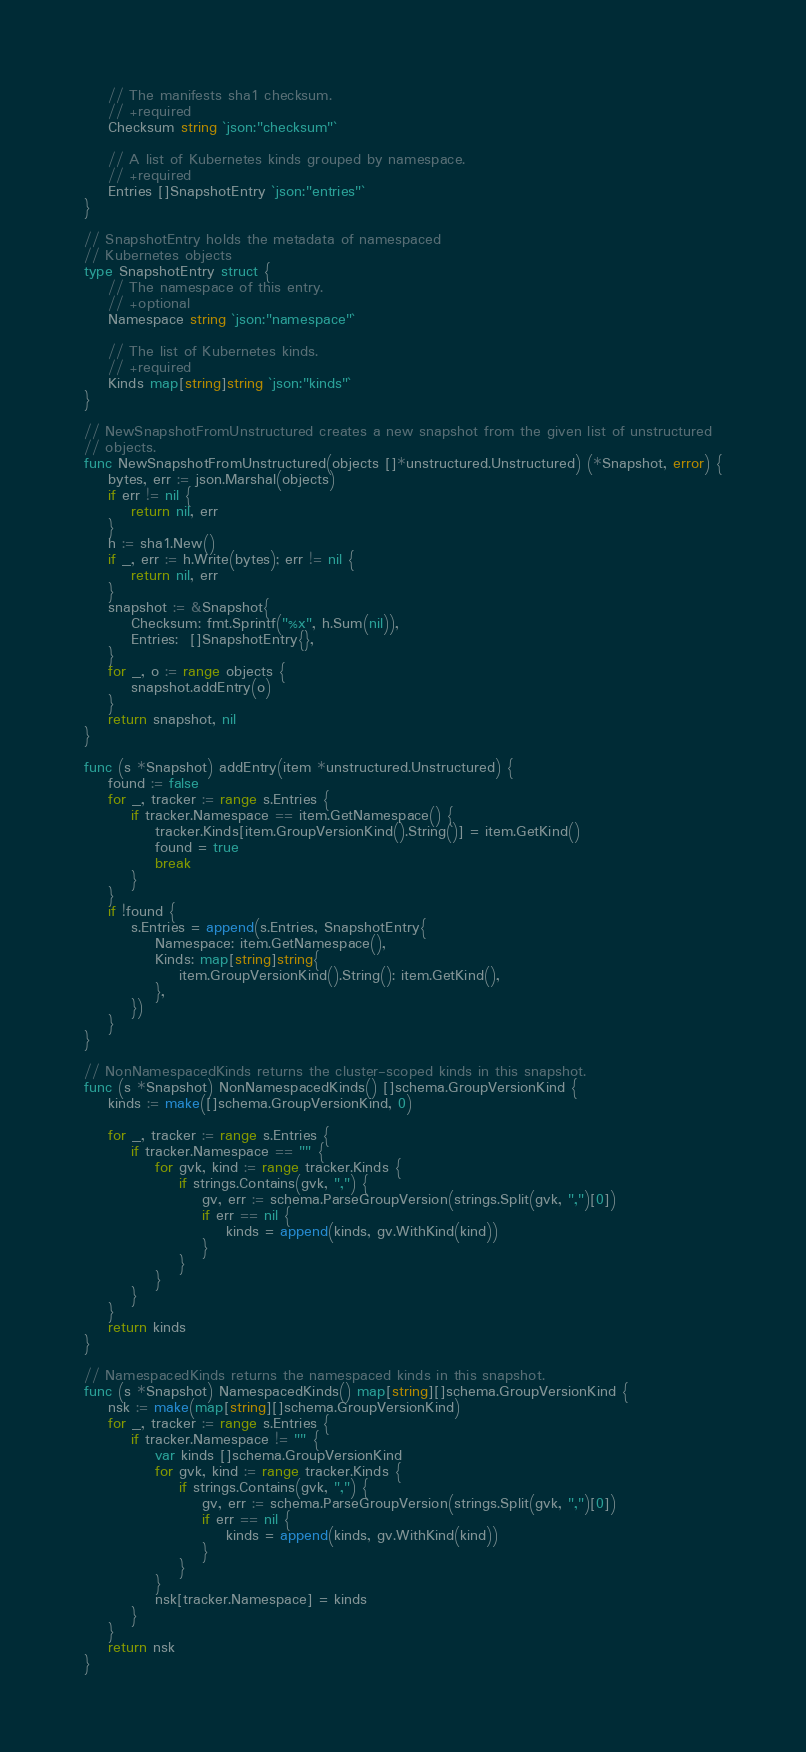Convert code to text. <code><loc_0><loc_0><loc_500><loc_500><_Go_>	// The manifests sha1 checksum.
	// +required
	Checksum string `json:"checksum"`

	// A list of Kubernetes kinds grouped by namespace.
	// +required
	Entries []SnapshotEntry `json:"entries"`
}

// SnapshotEntry holds the metadata of namespaced
// Kubernetes objects
type SnapshotEntry struct {
	// The namespace of this entry.
	// +optional
	Namespace string `json:"namespace"`

	// The list of Kubernetes kinds.
	// +required
	Kinds map[string]string `json:"kinds"`
}

// NewSnapshotFromUnstructured creates a new snapshot from the given list of unstructured
// objects.
func NewSnapshotFromUnstructured(objects []*unstructured.Unstructured) (*Snapshot, error) {
	bytes, err := json.Marshal(objects)
	if err != nil {
		return nil, err
	}
	h := sha1.New()
	if _, err := h.Write(bytes); err != nil {
		return nil, err
	}
	snapshot := &Snapshot{
		Checksum: fmt.Sprintf("%x", h.Sum(nil)),
		Entries:  []SnapshotEntry{},
	}
	for _, o := range objects {
		snapshot.addEntry(o)
	}
	return snapshot, nil
}

func (s *Snapshot) addEntry(item *unstructured.Unstructured) {
	found := false
	for _, tracker := range s.Entries {
		if tracker.Namespace == item.GetNamespace() {
			tracker.Kinds[item.GroupVersionKind().String()] = item.GetKind()
			found = true
			break
		}
	}
	if !found {
		s.Entries = append(s.Entries, SnapshotEntry{
			Namespace: item.GetNamespace(),
			Kinds: map[string]string{
				item.GroupVersionKind().String(): item.GetKind(),
			},
		})
	}
}

// NonNamespacedKinds returns the cluster-scoped kinds in this snapshot.
func (s *Snapshot) NonNamespacedKinds() []schema.GroupVersionKind {
	kinds := make([]schema.GroupVersionKind, 0)

	for _, tracker := range s.Entries {
		if tracker.Namespace == "" {
			for gvk, kind := range tracker.Kinds {
				if strings.Contains(gvk, ",") {
					gv, err := schema.ParseGroupVersion(strings.Split(gvk, ",")[0])
					if err == nil {
						kinds = append(kinds, gv.WithKind(kind))
					}
				}
			}
		}
	}
	return kinds
}

// NamespacedKinds returns the namespaced kinds in this snapshot.
func (s *Snapshot) NamespacedKinds() map[string][]schema.GroupVersionKind {
	nsk := make(map[string][]schema.GroupVersionKind)
	for _, tracker := range s.Entries {
		if tracker.Namespace != "" {
			var kinds []schema.GroupVersionKind
			for gvk, kind := range tracker.Kinds {
				if strings.Contains(gvk, ",") {
					gv, err := schema.ParseGroupVersion(strings.Split(gvk, ",")[0])
					if err == nil {
						kinds = append(kinds, gv.WithKind(kind))
					}
				}
			}
			nsk[tracker.Namespace] = kinds
		}
	}
	return nsk
}
</code> 